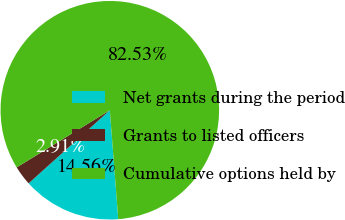Convert chart to OTSL. <chart><loc_0><loc_0><loc_500><loc_500><pie_chart><fcel>Net grants during the period<fcel>Grants to listed officers<fcel>Cumulative options held by<nl><fcel>14.56%<fcel>2.91%<fcel>82.52%<nl></chart> 